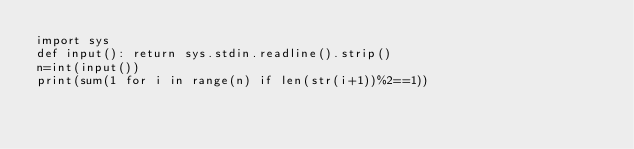Convert code to text. <code><loc_0><loc_0><loc_500><loc_500><_Python_>import sys
def input(): return sys.stdin.readline().strip()
n=int(input())
print(sum(1 for i in range(n) if len(str(i+1))%2==1))</code> 